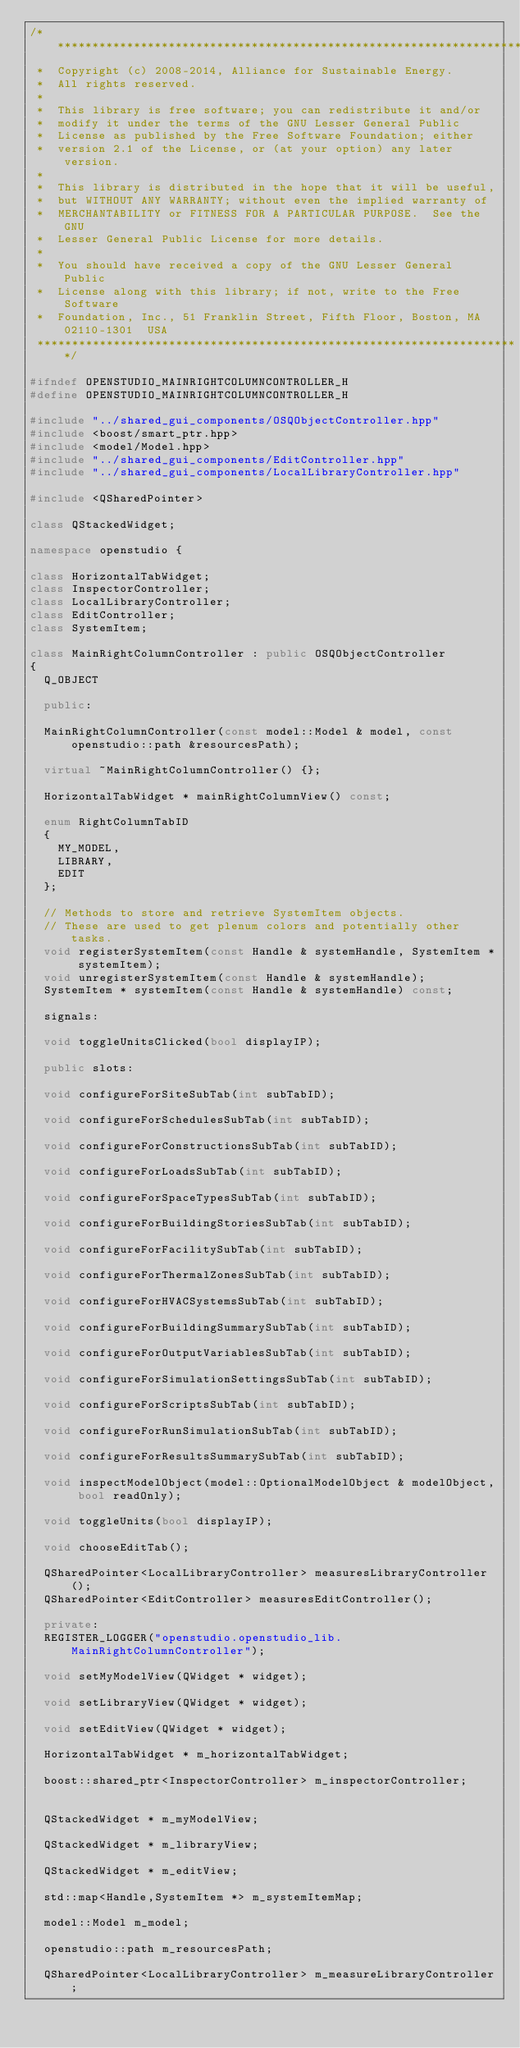<code> <loc_0><loc_0><loc_500><loc_500><_C++_>/**********************************************************************
 *  Copyright (c) 2008-2014, Alliance for Sustainable Energy.  
 *  All rights reserved.
 *  
 *  This library is free software; you can redistribute it and/or
 *  modify it under the terms of the GNU Lesser General Public
 *  License as published by the Free Software Foundation; either
 *  version 2.1 of the License, or (at your option) any later version.
 *  
 *  This library is distributed in the hope that it will be useful,
 *  but WITHOUT ANY WARRANTY; without even the implied warranty of
 *  MERCHANTABILITY or FITNESS FOR A PARTICULAR PURPOSE.  See the GNU
 *  Lesser General Public License for more details.
 *  
 *  You should have received a copy of the GNU Lesser General Public
 *  License along with this library; if not, write to the Free Software
 *  Foundation, Inc., 51 Franklin Street, Fifth Floor, Boston, MA  02110-1301  USA
 **********************************************************************/

#ifndef OPENSTUDIO_MAINRIGHTCOLUMNCONTROLLER_H
#define OPENSTUDIO_MAINRIGHTCOLUMNCONTROLLER_H

#include "../shared_gui_components/OSQObjectController.hpp"
#include <boost/smart_ptr.hpp>
#include <model/Model.hpp>
#include "../shared_gui_components/EditController.hpp"
#include "../shared_gui_components/LocalLibraryController.hpp"

#include <QSharedPointer>

class QStackedWidget;

namespace openstudio {

class HorizontalTabWidget;
class InspectorController;
class LocalLibraryController;
class EditController;
class SystemItem;

class MainRightColumnController : public OSQObjectController
{
  Q_OBJECT

  public:

  MainRightColumnController(const model::Model & model, const openstudio::path &resourcesPath);

  virtual ~MainRightColumnController() {};

  HorizontalTabWidget * mainRightColumnView() const;

  enum RightColumnTabID
  {
    MY_MODEL,
    LIBRARY,
    EDIT
  };

  // Methods to store and retrieve SystemItem objects.
  // These are used to get plenum colors and potentially other tasks.
  void registerSystemItem(const Handle & systemHandle, SystemItem * systemItem);
  void unregisterSystemItem(const Handle & systemHandle);
  SystemItem * systemItem(const Handle & systemHandle) const;

  signals:
  
  void toggleUnitsClicked(bool displayIP);

  public slots:

  void configureForSiteSubTab(int subTabID);

  void configureForSchedulesSubTab(int subTabID);

  void configureForConstructionsSubTab(int subTabID);

  void configureForLoadsSubTab(int subTabID);

  void configureForSpaceTypesSubTab(int subTabID);

  void configureForBuildingStoriesSubTab(int subTabID);

  void configureForFacilitySubTab(int subTabID);

  void configureForThermalZonesSubTab(int subTabID);

  void configureForHVACSystemsSubTab(int subTabID);

  void configureForBuildingSummarySubTab(int subTabID);

  void configureForOutputVariablesSubTab(int subTabID);

  void configureForSimulationSettingsSubTab(int subTabID);

  void configureForScriptsSubTab(int subTabID);

  void configureForRunSimulationSubTab(int subTabID);

  void configureForResultsSummarySubTab(int subTabID);

  void inspectModelObject(model::OptionalModelObject & modelObject, bool readOnly);

  void toggleUnits(bool displayIP);

  void chooseEditTab();

  QSharedPointer<LocalLibraryController> measuresLibraryController();
  QSharedPointer<EditController> measuresEditController();

  private:
  REGISTER_LOGGER("openstudio.openstudio_lib.MainRightColumnController");

  void setMyModelView(QWidget * widget);

  void setLibraryView(QWidget * widget);

  void setEditView(QWidget * widget);

  HorizontalTabWidget * m_horizontalTabWidget; 

  boost::shared_ptr<InspectorController> m_inspectorController;


  QStackedWidget * m_myModelView;

  QStackedWidget * m_libraryView;

  QStackedWidget * m_editView;

  std::map<Handle,SystemItem *> m_systemItemMap;

  model::Model m_model;

  openstudio::path m_resourcesPath;

  QSharedPointer<LocalLibraryController> m_measureLibraryController;</code> 